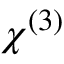<formula> <loc_0><loc_0><loc_500><loc_500>\chi ^ { ( 3 ) }</formula> 